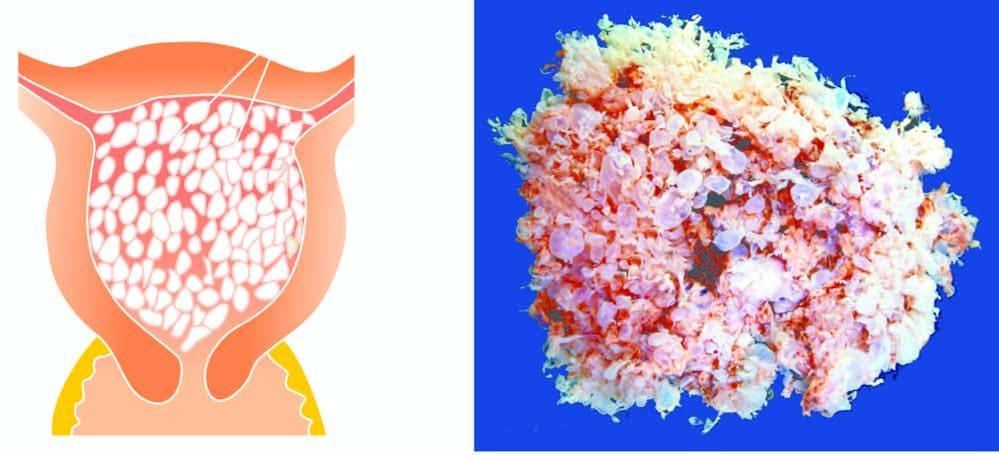re tan areas of haemorrhage also seen?
Answer the question using a single word or phrase. Yes 